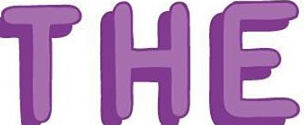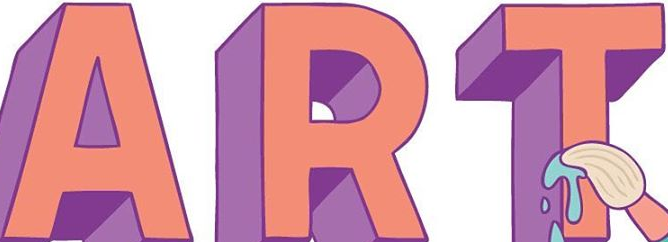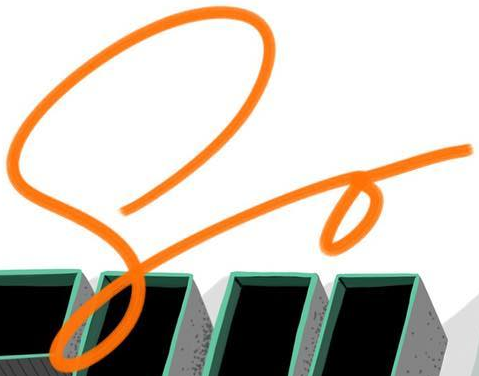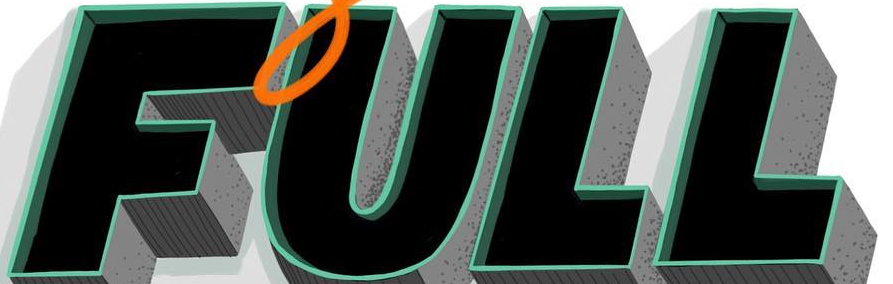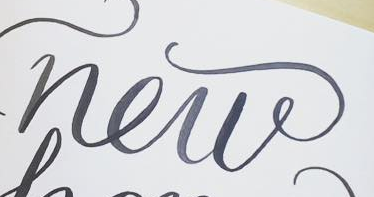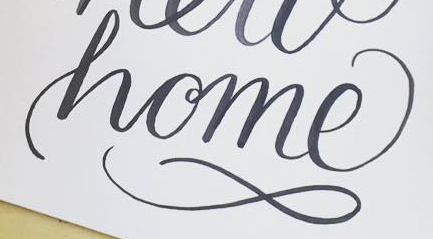What text is displayed in these images sequentially, separated by a semicolon? THE; ART; So; FULL; new; home 